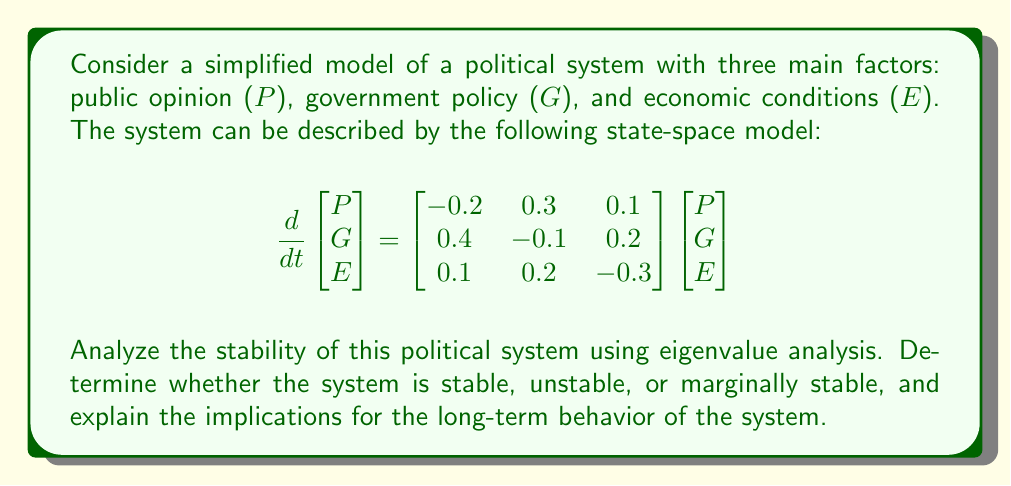Could you help me with this problem? To analyze the stability of the political system, we need to find the eigenvalues of the system matrix A:

$$A = \begin{bmatrix}-0.2 & 0.3 & 0.1 \\ 0.4 & -0.1 & 0.2 \\ 0.1 & 0.2 & -0.3\end{bmatrix}$$

Step 1: Calculate the characteristic equation
The characteristic equation is given by $\det(A - \lambda I) = 0$, where $\lambda$ represents the eigenvalues and I is the 3x3 identity matrix.

$$\det\begin{bmatrix}-0.2-\lambda & 0.3 & 0.1 \\ 0.4 & -0.1-\lambda & 0.2 \\ 0.1 & 0.2 & -0.3-\lambda\end{bmatrix} = 0$$

Expanding this determinant, we get:

$$-\lambda^3 - 0.6\lambda^2 - 0.07\lambda - 0.002 = 0$$

Step 2: Solve for the eigenvalues
Using a numerical method or a computer algebra system, we can find the roots of this polynomial:

$\lambda_1 \approx -0.5384$
$\lambda_2 \approx -0.0308 + 0.1825i$
$\lambda_3 \approx -0.0308 - 0.1825i$

Step 3: Analyze the stability
For a continuous-time system, stability is determined by the real parts of the eigenvalues:
- If all real parts are negative, the system is stable.
- If any real part is positive, the system is unstable.
- If the largest real part is zero (and the others are negative), the system is marginally stable.

In this case, all eigenvalues have negative real parts:
$Re(\lambda_1) = -0.5384 < 0$
$Re(\lambda_2) = Re(\lambda_3) = -0.0308 < 0$

Step 4: Interpret the results
Since all eigenvalues have negative real parts, the system is stable. This means that any perturbations in the system will eventually decay over time, and the system will return to its equilibrium state.

The eigenvalues also provide information about the system's behavior:
- $\lambda_1$ represents a fast-decaying mode (relatively large negative real part).
- $\lambda_2$ and $\lambda_3$ are complex conjugates, indicating an oscillatory behavior with slow decay.

In the context of the political system, this stability implies that:
1. The system is resilient to small disturbances in public opinion, government policy, or economic conditions.
2. There is a tendency for the system to return to a balanced state after perturbations.
3. The system may exhibit some oscillatory behavior (due to the complex eigenvalues) before settling, which could manifest as periodic fluctuations in public opinion, policy changes, or economic indicators.
4. The slowest decaying mode (associated with $\lambda_2$ and $\lambda_3$) will dominate the long-term behavior of the system, suggesting that some effects may persist for an extended period before fully dissipating.
Answer: The political system is stable. All eigenvalues ($\lambda_1 \approx -0.5384$, $\lambda_2 \approx -0.0308 + 0.1825i$, $\lambda_3 \approx -0.0308 - 0.1825i$) have negative real parts, indicating that perturbations will decay over time. The system will exhibit both fast-decaying and slow oscillatory behaviors before returning to equilibrium. 